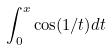<formula> <loc_0><loc_0><loc_500><loc_500>\int _ { 0 } ^ { x } \cos ( 1 / t ) d t</formula> 